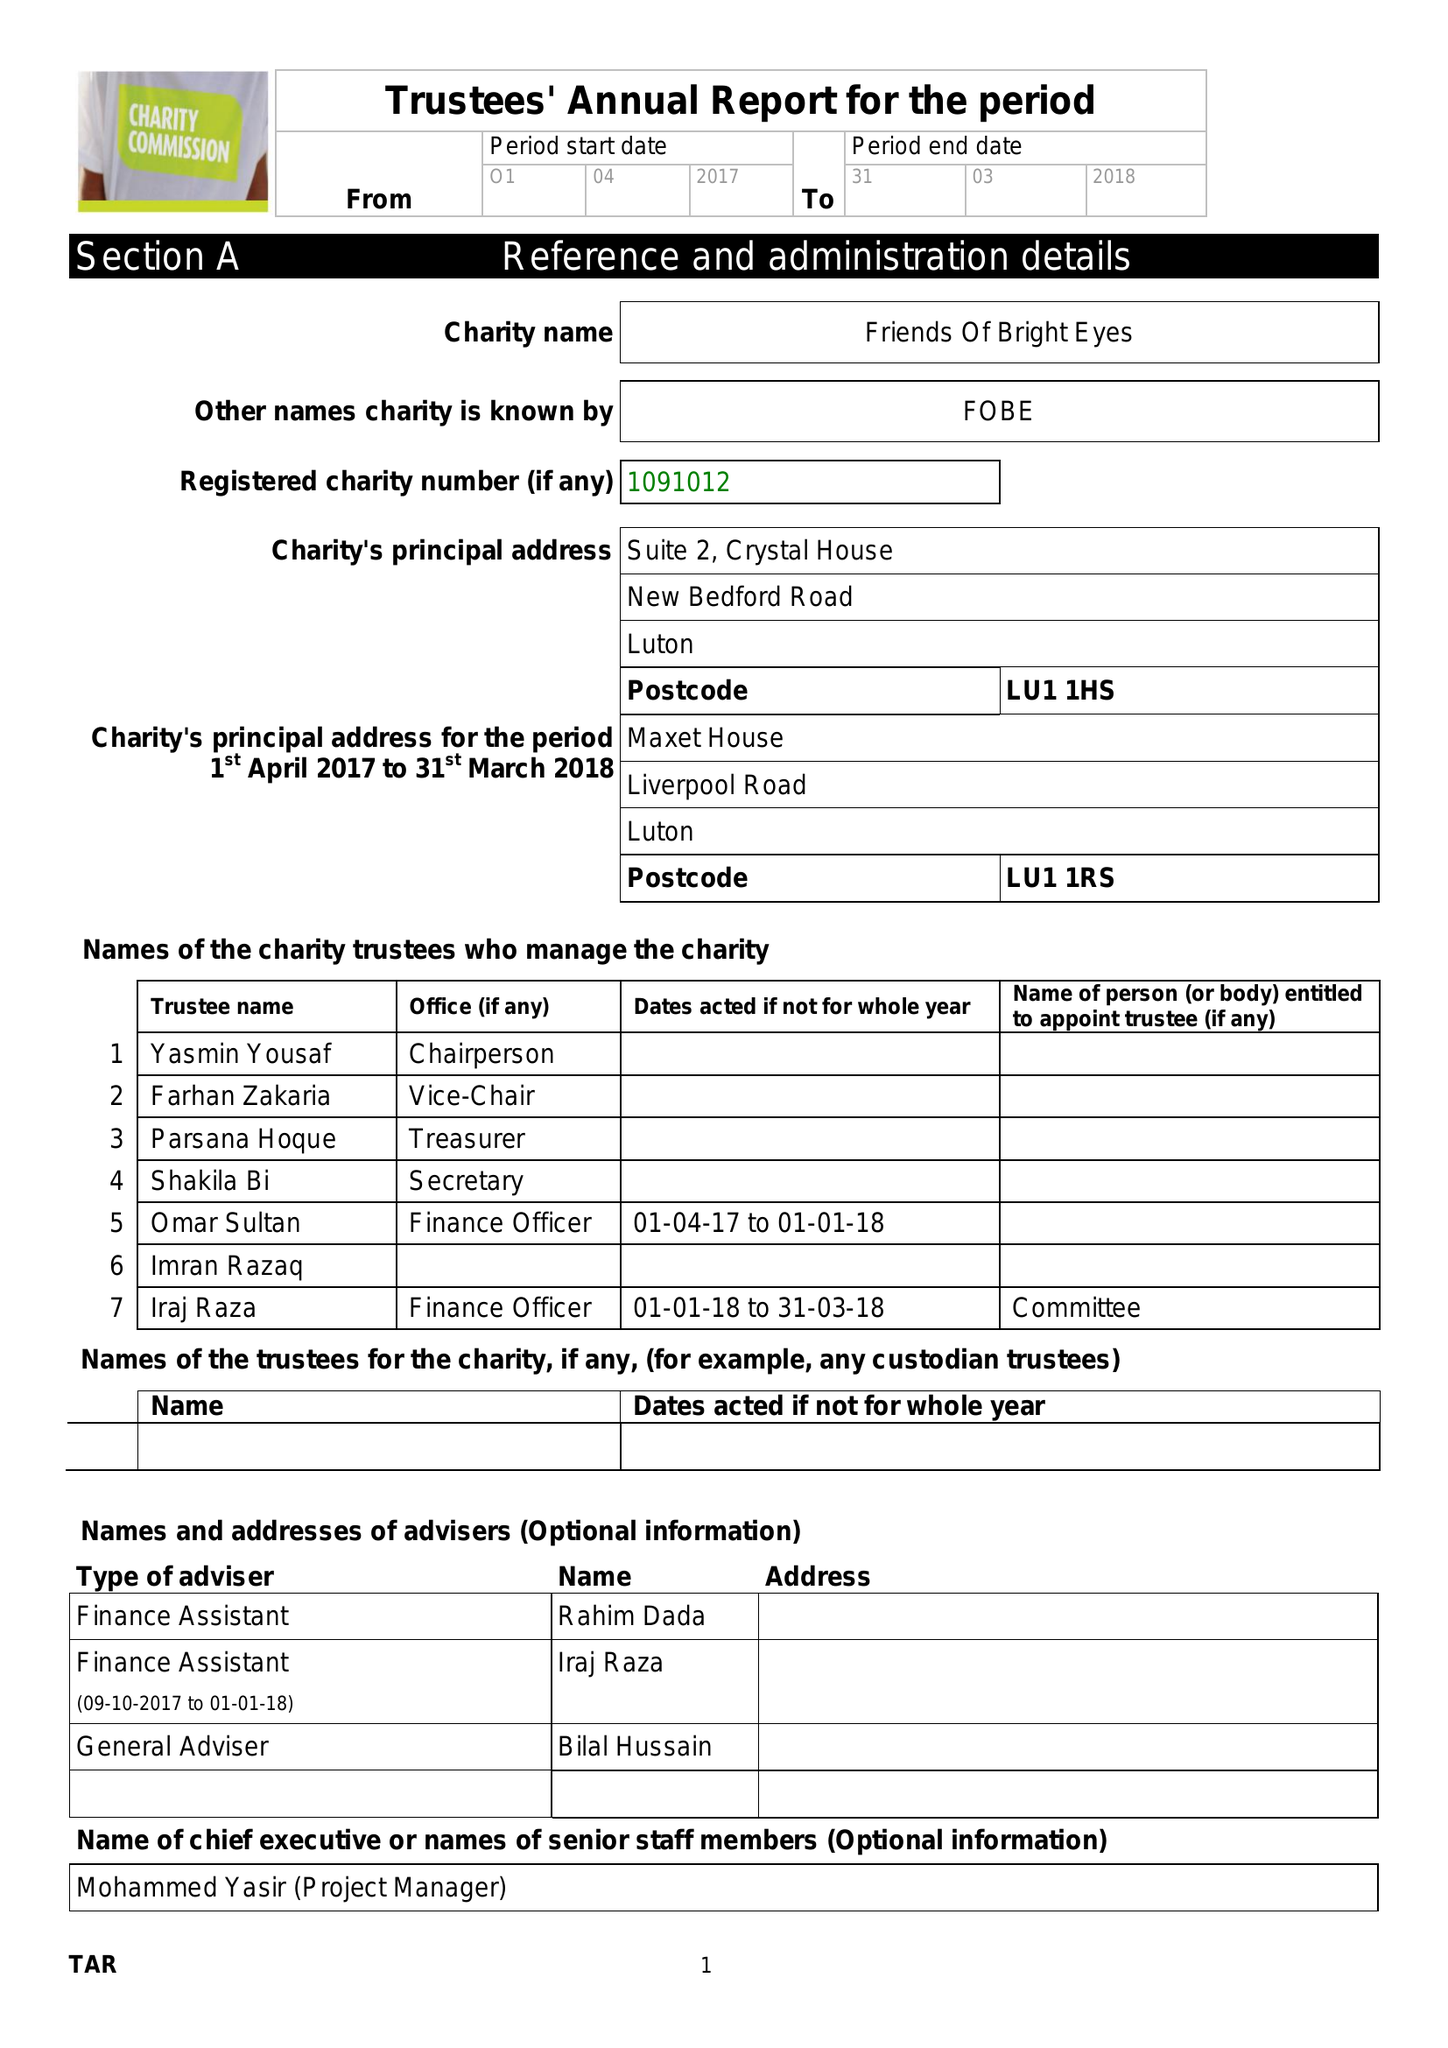What is the value for the address__street_line?
Answer the question using a single word or phrase. NEW BEDFORD ROAD 